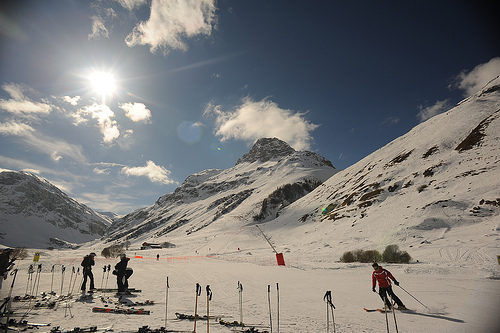How many skiers can be seen on the slope? There are four skiers visible on the slope, enjoying the clear weather and snowy conditions. 